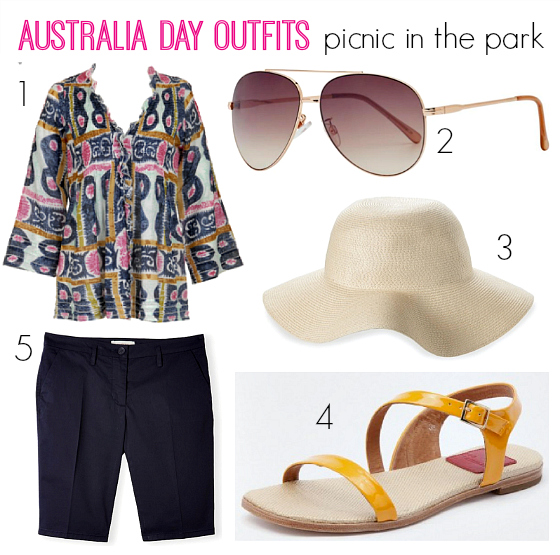How would you style the sun hat for a formal event? For a formal event, I would recommend styling the sun hat with a sophisticated midi or maxi dress in a solid color or a subtle floral pattern to keep it elegant but not overwhelming. Pair it with minimalist sandals or heels and a classy clutch. Add a subtle necklace or a pair of drop earrings for a complete look that remains stylish yet appropriate for formal occasions. 